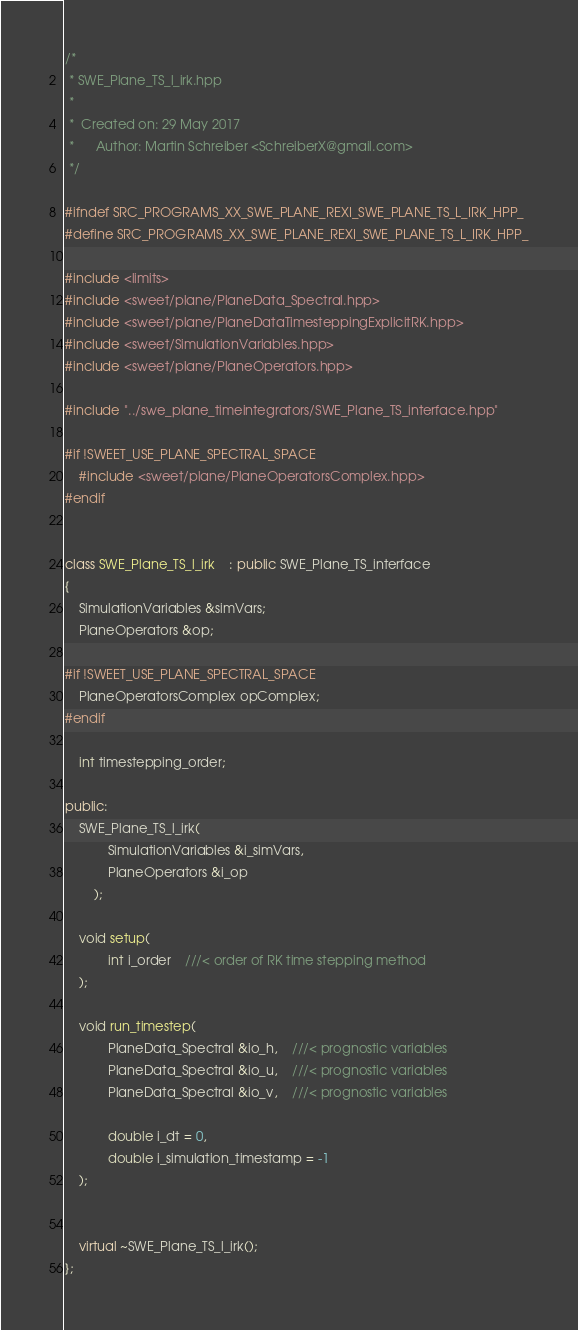<code> <loc_0><loc_0><loc_500><loc_500><_C++_>/*
 * SWE_Plane_TS_l_irk.hpp
 *
 *  Created on: 29 May 2017
 *      Author: Martin Schreiber <SchreiberX@gmail.com>
 */

#ifndef SRC_PROGRAMS_XX_SWE_PLANE_REXI_SWE_PLANE_TS_L_IRK_HPP_
#define SRC_PROGRAMS_XX_SWE_PLANE_REXI_SWE_PLANE_TS_L_IRK_HPP_

#include <limits>
#include <sweet/plane/PlaneData_Spectral.hpp>
#include <sweet/plane/PlaneDataTimesteppingExplicitRK.hpp>
#include <sweet/SimulationVariables.hpp>
#include <sweet/plane/PlaneOperators.hpp>

#include "../swe_plane_timeintegrators/SWE_Plane_TS_interface.hpp"

#if !SWEET_USE_PLANE_SPECTRAL_SPACE
	#include <sweet/plane/PlaneOperatorsComplex.hpp>
#endif


class SWE_Plane_TS_l_irk	: public SWE_Plane_TS_interface
{
	SimulationVariables &simVars;
	PlaneOperators &op;

#if !SWEET_USE_PLANE_SPECTRAL_SPACE
	PlaneOperatorsComplex opComplex;
#endif

	int timestepping_order;

public:
	SWE_Plane_TS_l_irk(
			SimulationVariables &i_simVars,
			PlaneOperators &i_op
		);

	void setup(
			int i_order	///< order of RK time stepping method
	);

	void run_timestep(
			PlaneData_Spectral &io_h,	///< prognostic variables
			PlaneData_Spectral &io_u,	///< prognostic variables
			PlaneData_Spectral &io_v,	///< prognostic variables

			double i_dt = 0,
			double i_simulation_timestamp = -1
	);


	virtual ~SWE_Plane_TS_l_irk();
};
</code> 